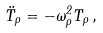Convert formula to latex. <formula><loc_0><loc_0><loc_500><loc_500>\ddot { T } _ { \rho } = - \omega _ { \rho } ^ { 2 } T _ { \rho } \, ,</formula> 